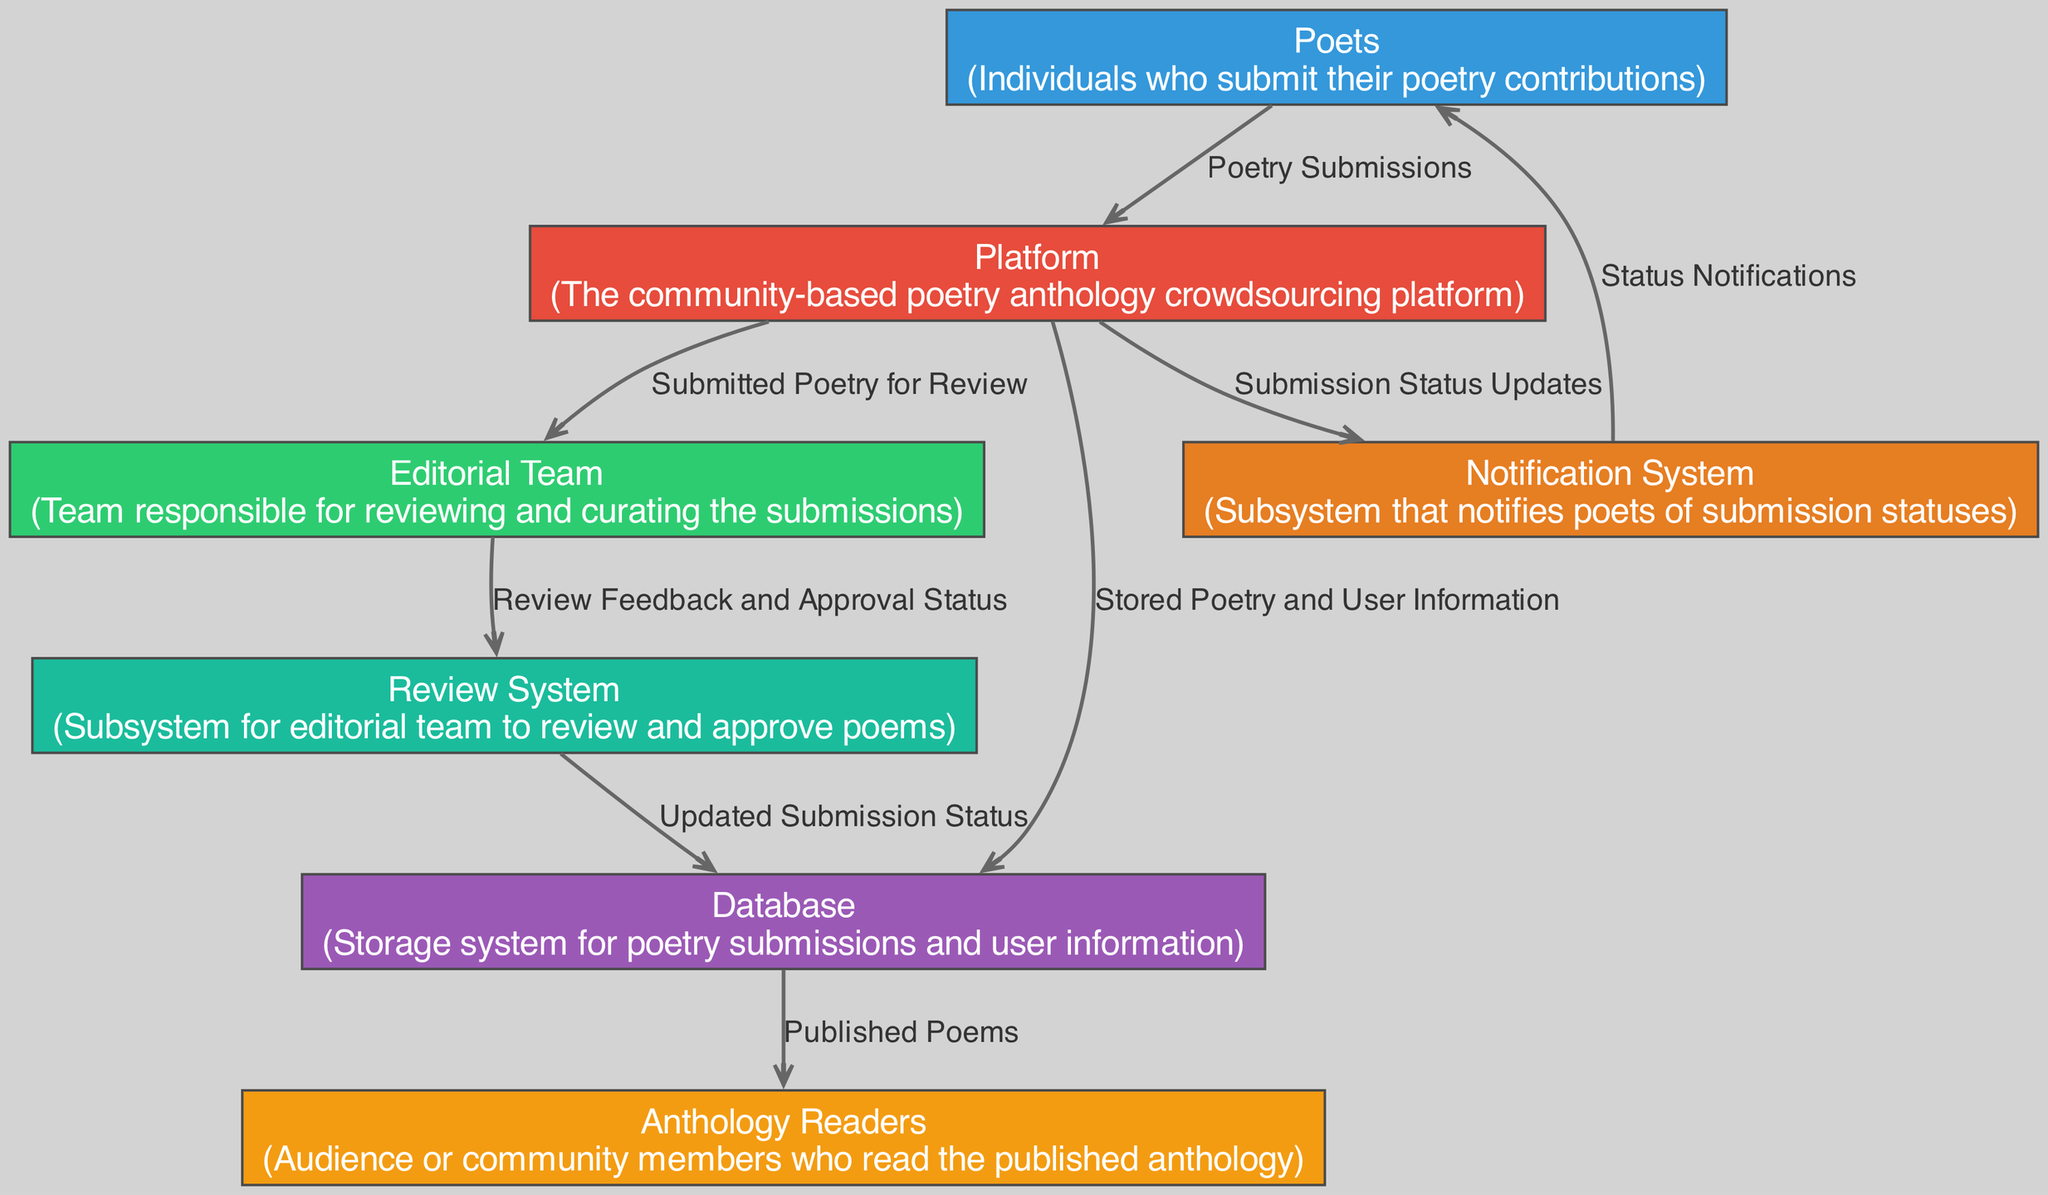What is the total number of entities in the diagram? The diagram lists six distinct entities, which are Poets, Platform, Editorial Team, Anthology Readers, Database, Review System, and Notification System.
Answer: 6 What does the Editorial Team receive from the Platform? The platform sends "Submitted Poetry for Review" to the Editorial Team as demonstrated by the flow in the diagram that connects these two entities.
Answer: Submitted Poetry for Review Which entity is responsible for notifying Poets of their submission statuses? The Notification System is responsible for sending "Status Notifications" to Poets as indicated in the data flow from Notification System to Poets.
Answer: Notification System How many data flows originate from the Database? There are two data flows that start at the Database: one going to Anthology Readers with "Published Poems" and another to Review System with "Updated Submission Status".
Answer: 2 Which entity curates submissions before they are published? The Editorial Team is responsible for reviewing and curating submissions, as seen in the relationship where they receive poetry to review from the Platform.
Answer: Editorial Team What does the Notification System send to Poets? The Notification System sends "Status Notifications" to Poets, as indicated by the flow connecting these two entities in the diagram.
Answer: Status Notifications Which system does the Editorial Team use to communicate feedback? The Editorial Team utilizes the Review System to convey "Review Feedback and Approval Status", which is shown by the flow from Editorial Team to Review System.
Answer: Review System How is poetry and user information stored in the system? Poetry and user information is stored in the Database after being sent from the Platform, as per the data flow shown in the diagram.
Answer: Database What type of audience interacts with the published anthology? The audience that interacts with the published anthology is referred to as Anthology Readers, according to the flow from Database to this entity.
Answer: Anthology Readers 